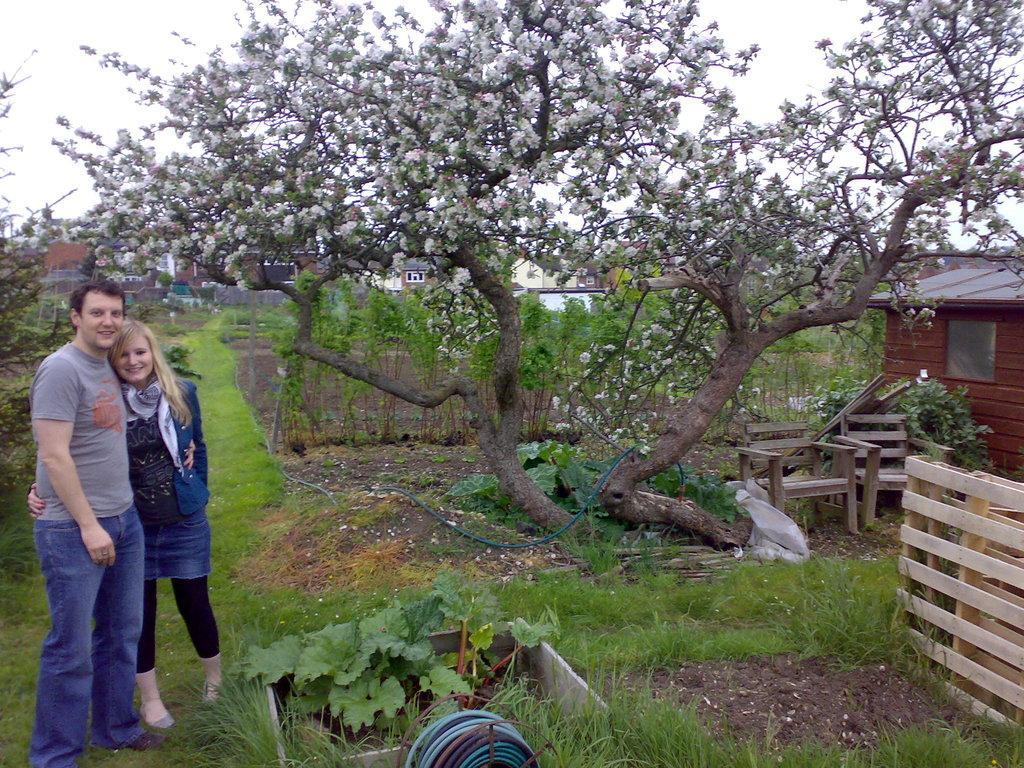Describe this image in one or two sentences. In this picture I can observe a couple on the left side. Both of them are smiling. In the middle of the picture I can observe a tree. In the background there is sky. 